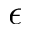<formula> <loc_0><loc_0><loc_500><loc_500>\epsilon</formula> 